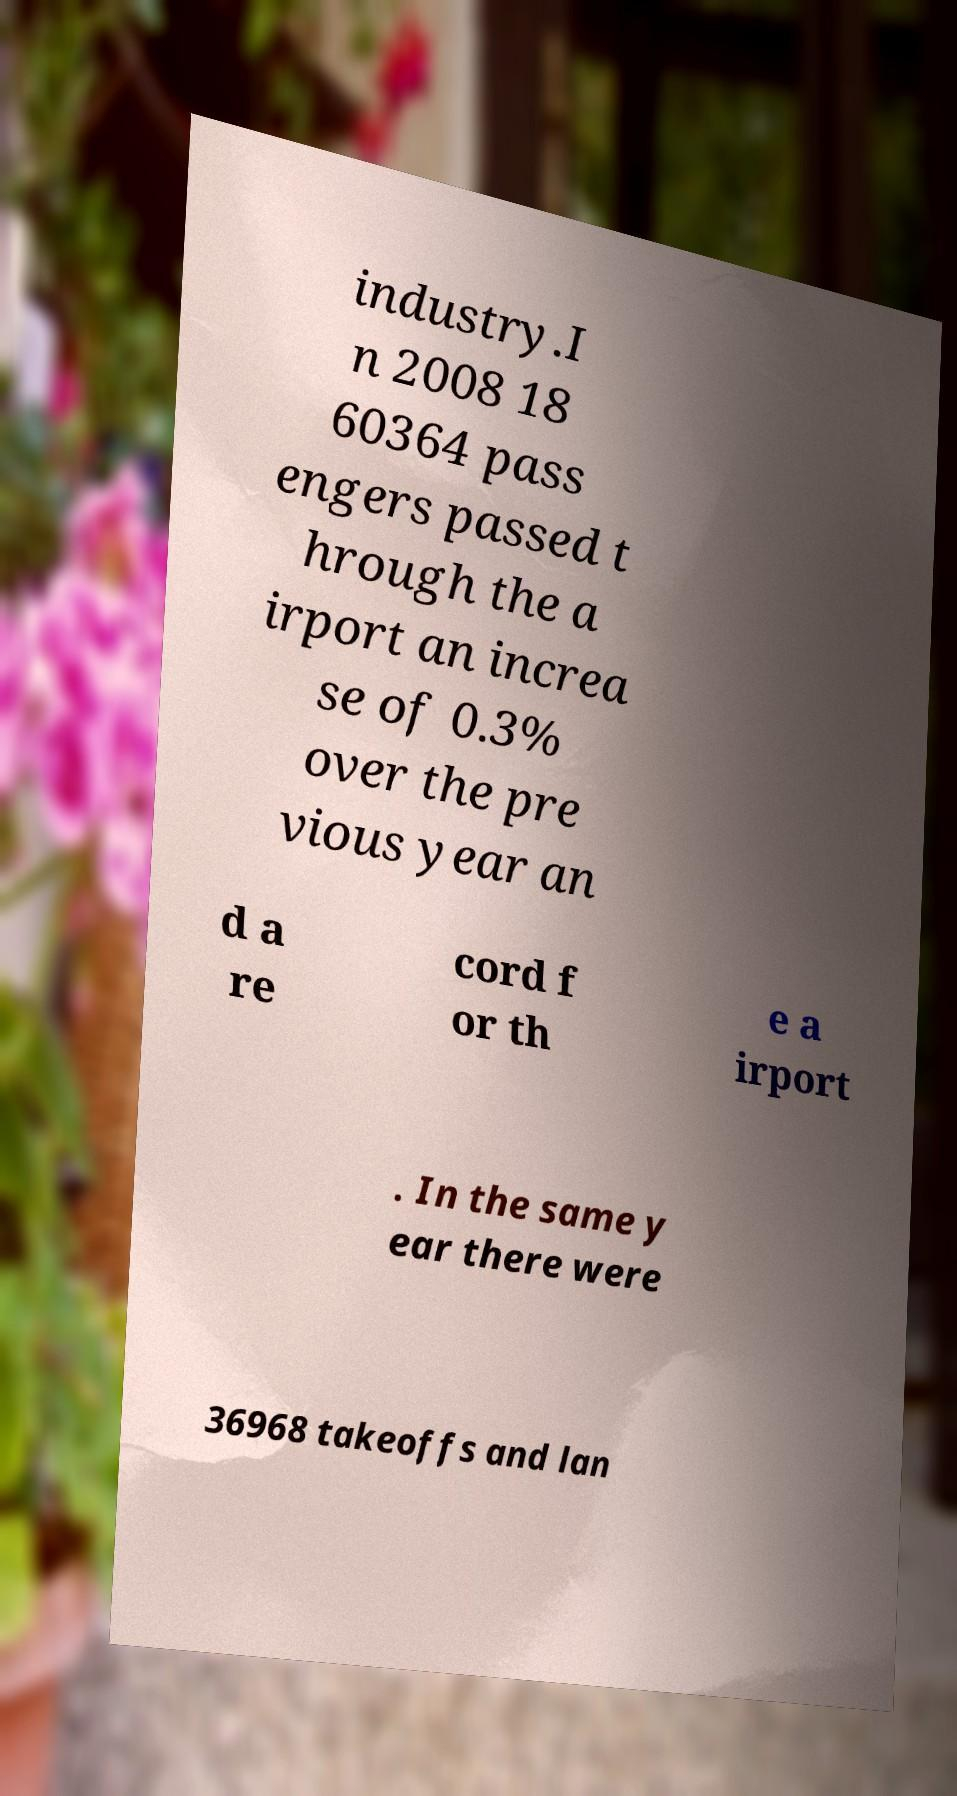There's text embedded in this image that I need extracted. Can you transcribe it verbatim? industry.I n 2008 18 60364 pass engers passed t hrough the a irport an increa se of 0.3% over the pre vious year an d a re cord f or th e a irport . In the same y ear there were 36968 takeoffs and lan 